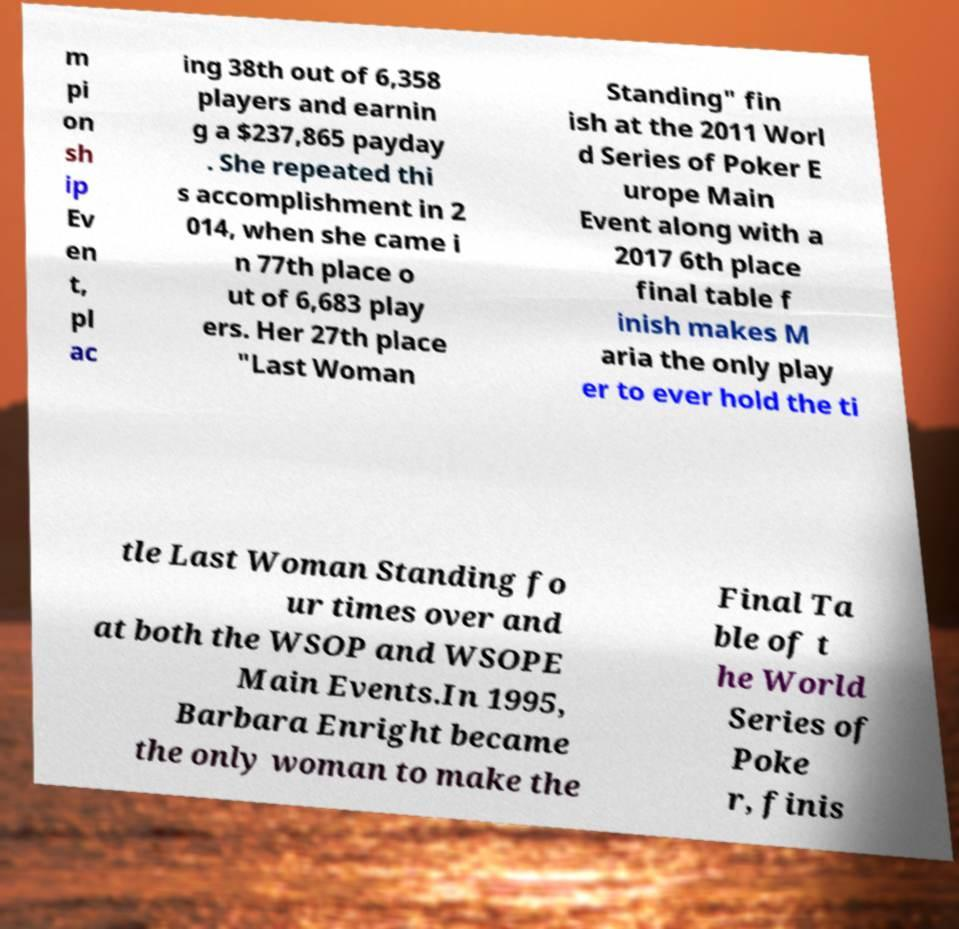Can you read and provide the text displayed in the image?This photo seems to have some interesting text. Can you extract and type it out for me? m pi on sh ip Ev en t, pl ac ing 38th out of 6,358 players and earnin g a $237,865 payday . She repeated thi s accomplishment in 2 014, when she came i n 77th place o ut of 6,683 play ers. Her 27th place "Last Woman Standing" fin ish at the 2011 Worl d Series of Poker E urope Main Event along with a 2017 6th place final table f inish makes M aria the only play er to ever hold the ti tle Last Woman Standing fo ur times over and at both the WSOP and WSOPE Main Events.In 1995, Barbara Enright became the only woman to make the Final Ta ble of t he World Series of Poke r, finis 